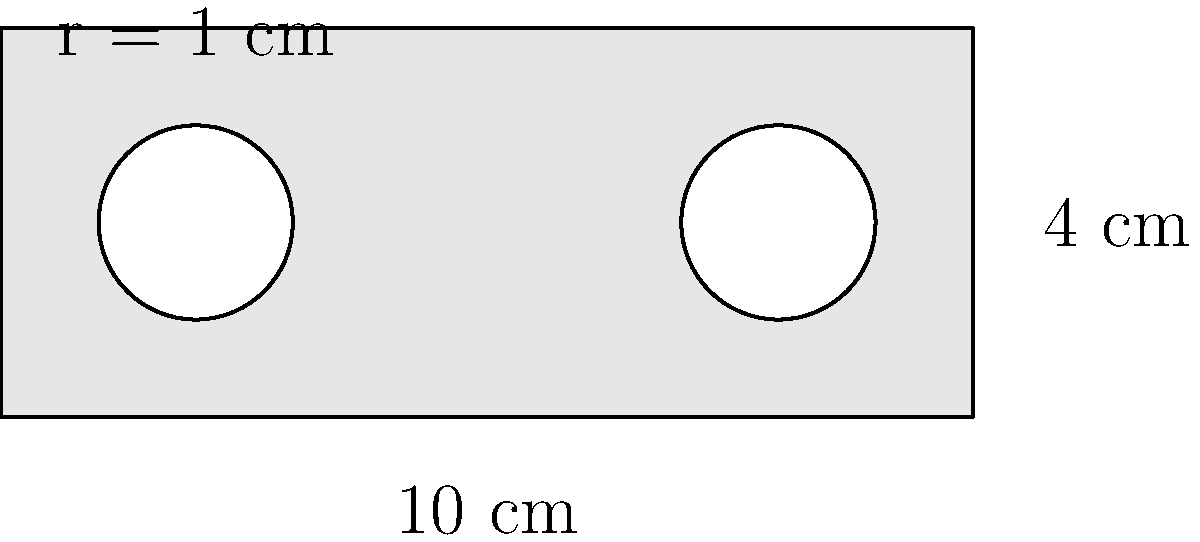A traditional wampum belt is represented by a rectangle with two circular designs. The belt measures 10 cm in length and 4 cm in width. Two circular designs, each with a radius of 1 cm, are placed within the rectangle. Calculate the area of the wampum belt material, excluding the circular designs. To find the area of the wampum belt material, we need to:

1. Calculate the total area of the rectangle:
   $A_{rectangle} = length \times width = 10 \text{ cm} \times 4 \text{ cm} = 40 \text{ cm}^2$

2. Calculate the area of one circular design:
   $A_{circle} = \pi r^2 = \pi \times (1 \text{ cm})^2 = \pi \text{ cm}^2$

3. Calculate the total area of both circular designs:
   $A_{total circles} = 2 \times \pi \text{ cm}^2 = 2\pi \text{ cm}^2$

4. Subtract the area of the circular designs from the rectangle's area:
   $A_{wampum belt} = A_{rectangle} - A_{total circles}$
   $A_{wampum belt} = 40 \text{ cm}^2 - 2\pi \text{ cm}^2$
   $A_{wampum belt} = (40 - 2\pi) \text{ cm}^2$

5. Simplify the result:
   $A_{wampum belt} \approx 33.72 \text{ cm}^2$ (rounded to two decimal places)
Answer: $(40 - 2\pi) \text{ cm}^2$ or approximately $33.72 \text{ cm}^2$ 